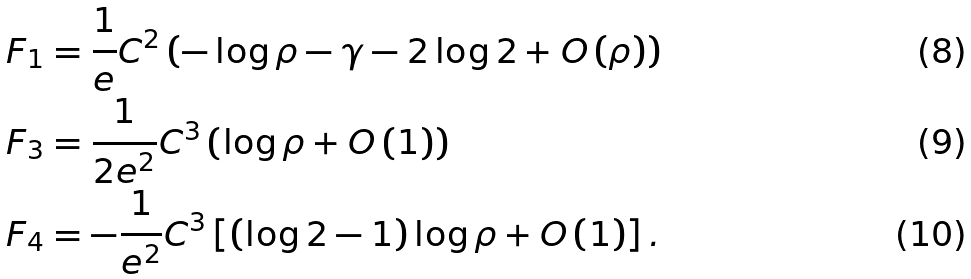Convert formula to latex. <formula><loc_0><loc_0><loc_500><loc_500>F _ { 1 } & = \frac { 1 } { e } C ^ { 2 } \left ( - \log \rho - \gamma - 2 \log 2 + O \left ( \rho \right ) \right ) \text { } \\ F _ { 3 } & = \frac { 1 } { 2 e ^ { 2 } } C ^ { 3 } \left ( \log \rho + O \left ( 1 \right ) \right ) \\ F _ { 4 } & = - \frac { 1 } { e ^ { 2 } } C ^ { 3 } \left [ \left ( \log 2 - 1 \right ) \log \rho + O \left ( 1 \right ) \right ] .</formula> 